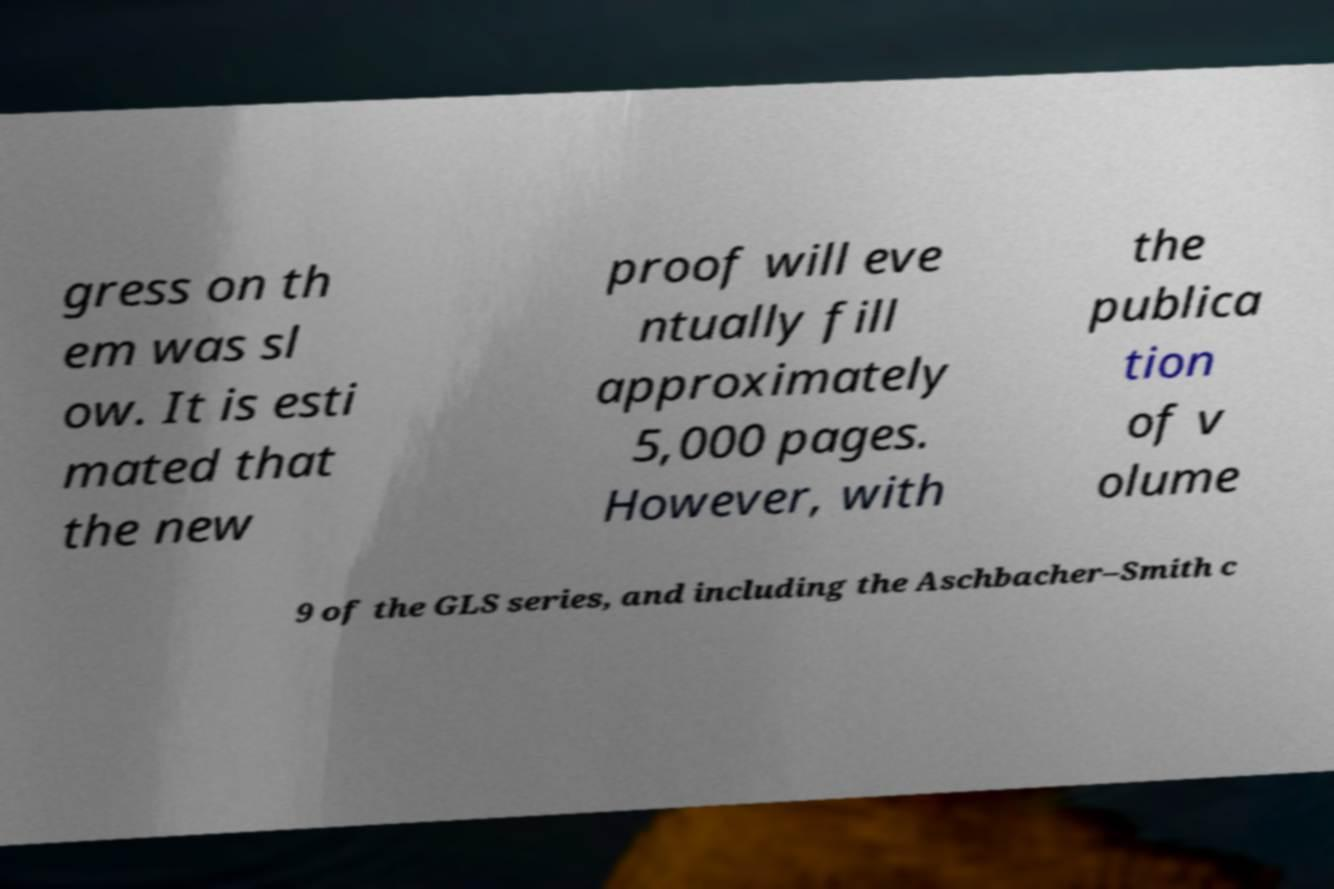Please identify and transcribe the text found in this image. gress on th em was sl ow. It is esti mated that the new proof will eve ntually fill approximately 5,000 pages. However, with the publica tion of v olume 9 of the GLS series, and including the Aschbacher–Smith c 